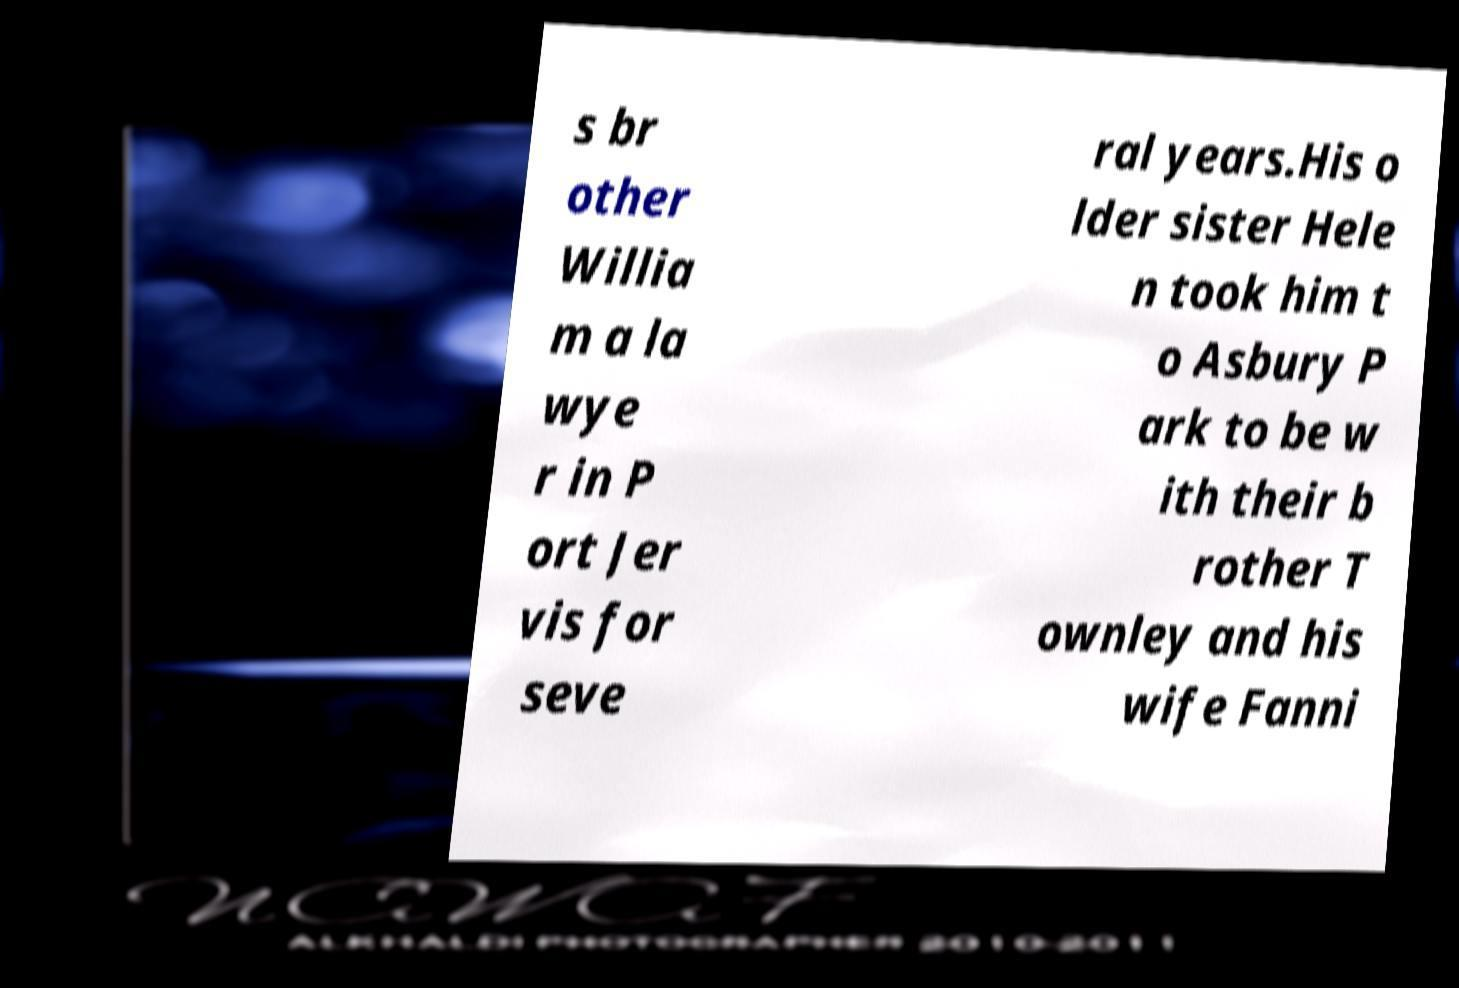Can you accurately transcribe the text from the provided image for me? s br other Willia m a la wye r in P ort Jer vis for seve ral years.His o lder sister Hele n took him t o Asbury P ark to be w ith their b rother T ownley and his wife Fanni 